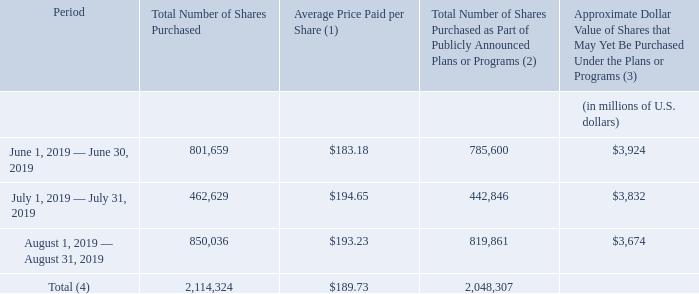Purchases of Accenture plc Class A Ordinary Shares
The following table provides information relating to our purchases of Accenture plc Class A ordinary shares during the fourth quarter of fiscal 2019. For year-to-date information on all of our share purchases, redemptions and exchanges and further discussion of our share purchase activity, see “Management’s Discussion and Analysis of Financial Condition and Results of Operations—Liquidity and Capital Resources—Share Purchases and Redemptions.”
(1) Average price paid per share reflects the total cash outlay for the period, divided by the number of shares acquired, including those acquired by purchase or redemption for cash and any acquired by means of employee forfeiture.
(2) Since August 2001, the Board of Directors of Accenture plc has authorized and periodically confirmed a publicly
announced open-market share purchase program for acquiring Accenture plc Class A ordinary shares. During
the fourth quarter of fiscal 2019, we purchased 2,048,307 Accenture plc Class A ordinary shares under this
program for an aggregate price of $389 million. The open-market purchase program does not have an expiration
date
(3) As of August 31, 2019, our aggregate available authorization for share purchases and redemptions was $3,674 million, which management has the discretion to use for either our publicly announced open-market share purchase program or our other share purchase programs. Since August 2001 and as of August 31, 2019, the Board of Directors of Accenture plc has authorized an aggregate of $35.1 billion for share purchases and redemptions by Accenture plc and Accenture Canada Holdings Inc
(4) During the fourth quarter of fiscal 2019, Accenture purchased 66,017 Accenture plc Class A ordinary shares in transactions unrelated to publicly announced share plans or programs. These transactions consisted of acquisitions of Accenture plc Class A ordinary shares primarily via share withholding for payroll tax obligations due from employees and former employees in connection with the delivery of Accenture plc Class A ordinary shares under our various employee equity share plans. These purchases of shares in connection with employee share plans do not affect our aggregate available authorization for our publicly announced open-market share purchase and our other share purchase programs.
What is the total number of shares purchased in 2019? 2,114,324. When did Accenture's Board of Directors authorize and confirm an open-market share purchase program for acquiring Accenture pls Class A ordinary shares? August 2001. How is average price per share determined? Average price paid per share reflects the total cash outlay for the period, divided by the number of shares acquired, including those acquired by purchase or redemption for cash and any acquired by means of employee forfeiture. What is the total number of shares purchased by July 31, 2019? 801,659 + 462,629 
Answer: 1264288. What is Accenture's average share price paid per share for June and July of 2019? (801,659*183.18 + 462,629*194.65)/(801,659+462,629) 
Answer: 187.38. How much of the shares purchased in July were part of publicly announced plan or programs?
Answer scale should be: percent. 442,846/462,629 
Answer: 95.72. 